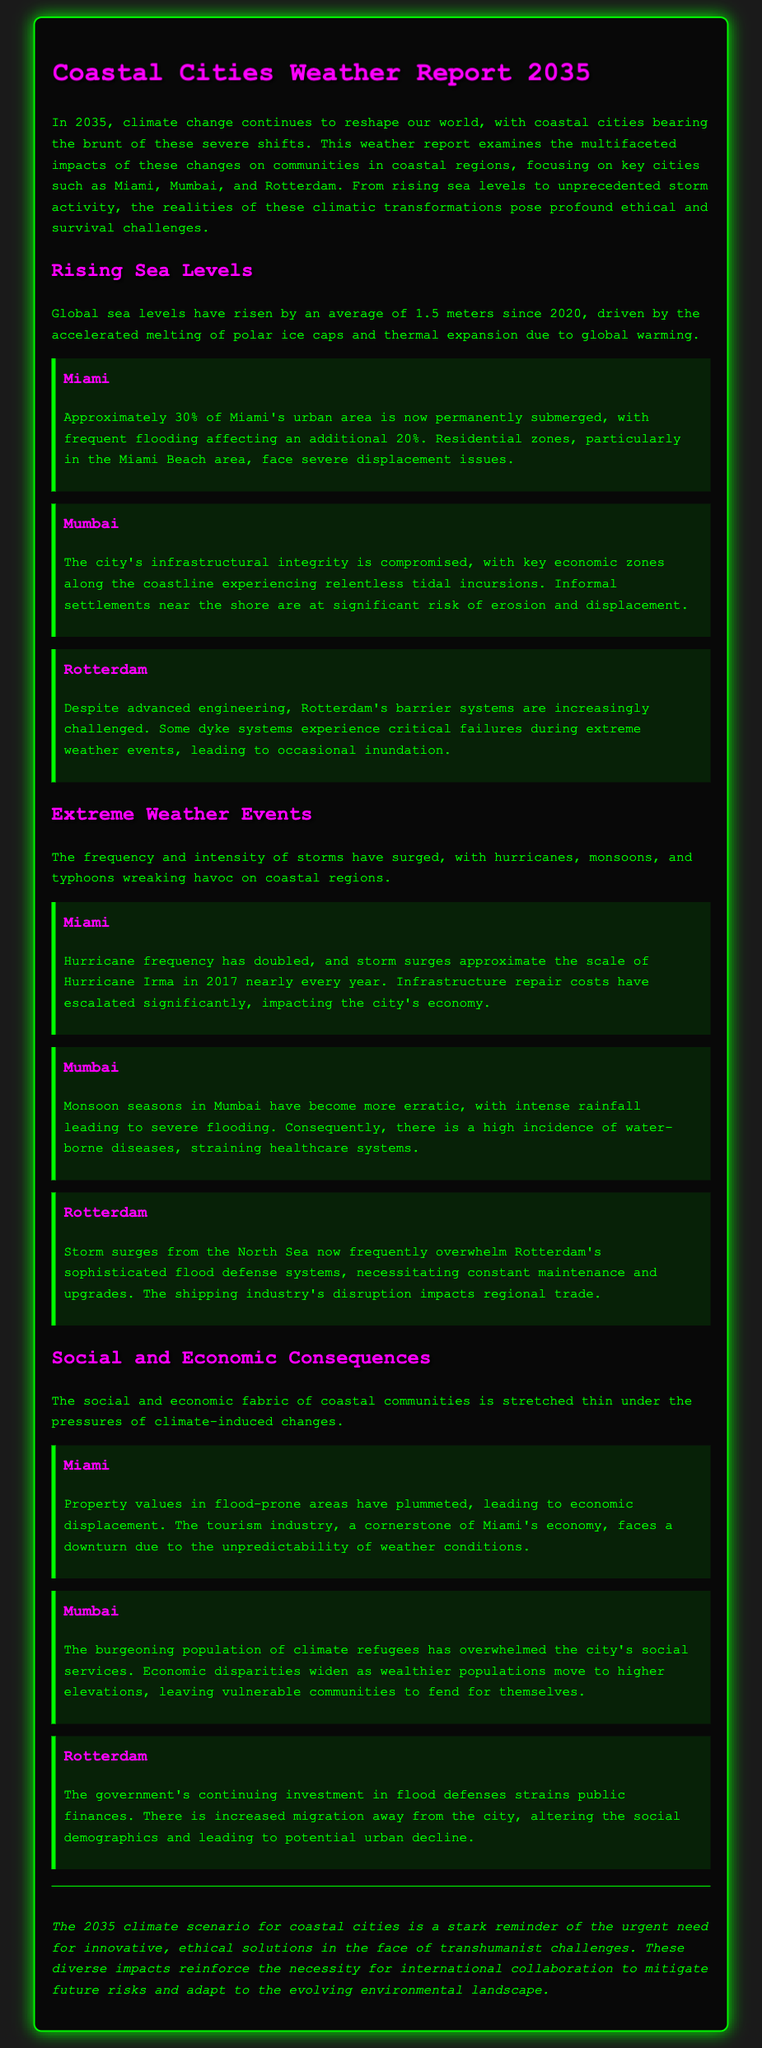What is the average rise in sea levels since 2020? The average rise in sea levels is stated as 1.5 meters since 2020.
Answer: 1.5 meters Which city has approximately 30% of its area submerged? The document specifically mentions Miami having approximately 30% of its urban area permanently submerged.
Answer: Miami What natural disaster frequency has doubled in Miami? The report indicates that hurricane frequency has doubled in Miami.
Answer: Hurricane What has overwhelmed Mumbai's social services? The document describes the burgeoning population of climate refugees as overwhelming Mumbai's social services.
Answer: Climate refugees What has led to economic disparities in Mumbai? The report mentions that wealthier populations moving to higher elevations has widened economic disparities.
Answer: Wealthier populations What is the impact of storm surges on Rotterdam's flood defense systems? The document states that storm surges from the North Sea frequently overwhelm Rotterdam's flood defense systems.
Answer: Frequently overwhelm What economic sector in Miami faces a downturn? The tourism industry in Miami is facing a downturn due to unpredictable weather conditions.
Answer: Tourism industry What is the conclusion about the 2035 climate scenario for coastal cities? The conclusion emphasizes the urgent need for innovative, ethical solutions in response to climate change impacts on coastal cities.
Answer: Urgent need for innovative, ethical solutions 